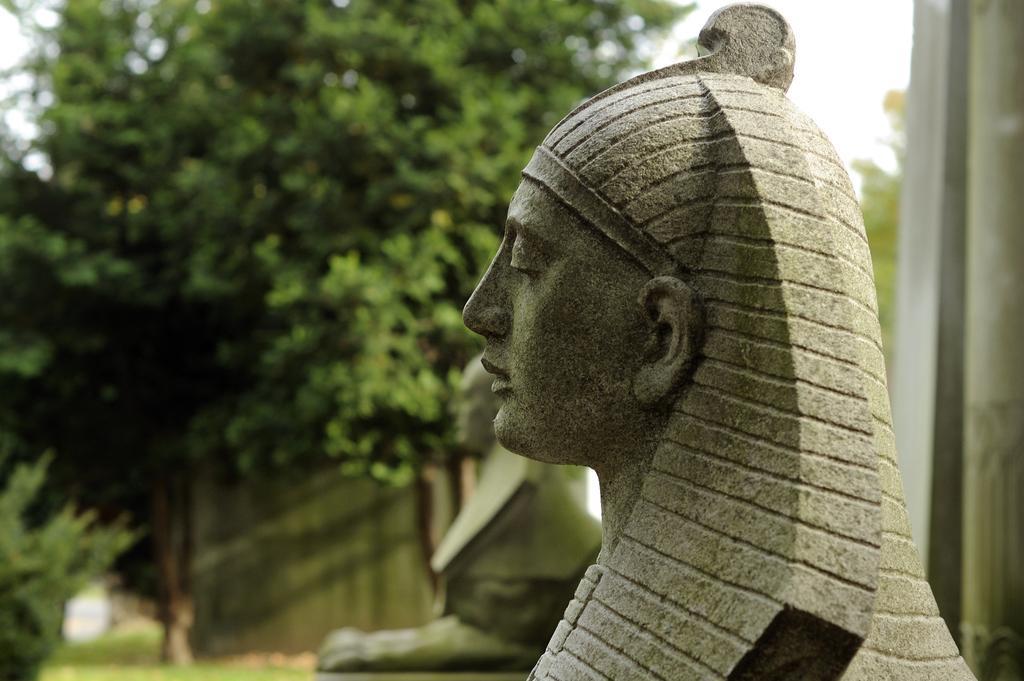Could you give a brief overview of what you see in this image? In this image I can see two sculptures facing towards the left side. In the background there are some trees. At the top of the image I can see the sky. 